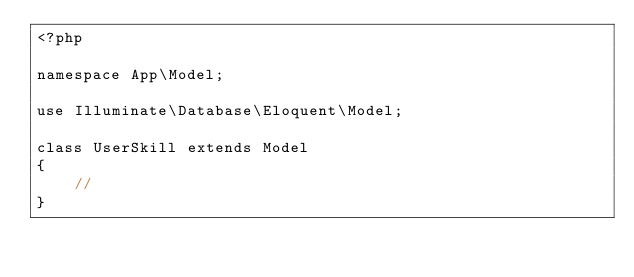Convert code to text. <code><loc_0><loc_0><loc_500><loc_500><_PHP_><?php

namespace App\Model;

use Illuminate\Database\Eloquent\Model;

class UserSkill extends Model
{
    //
}
</code> 